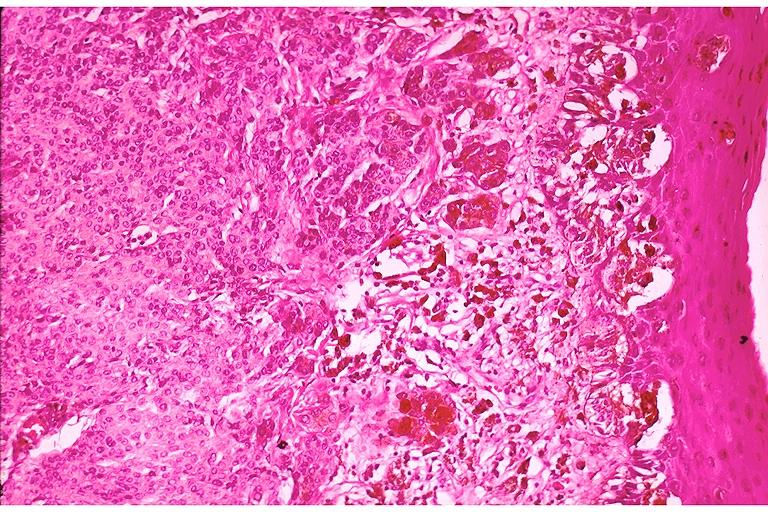s oral present?
Answer the question using a single word or phrase. Yes 